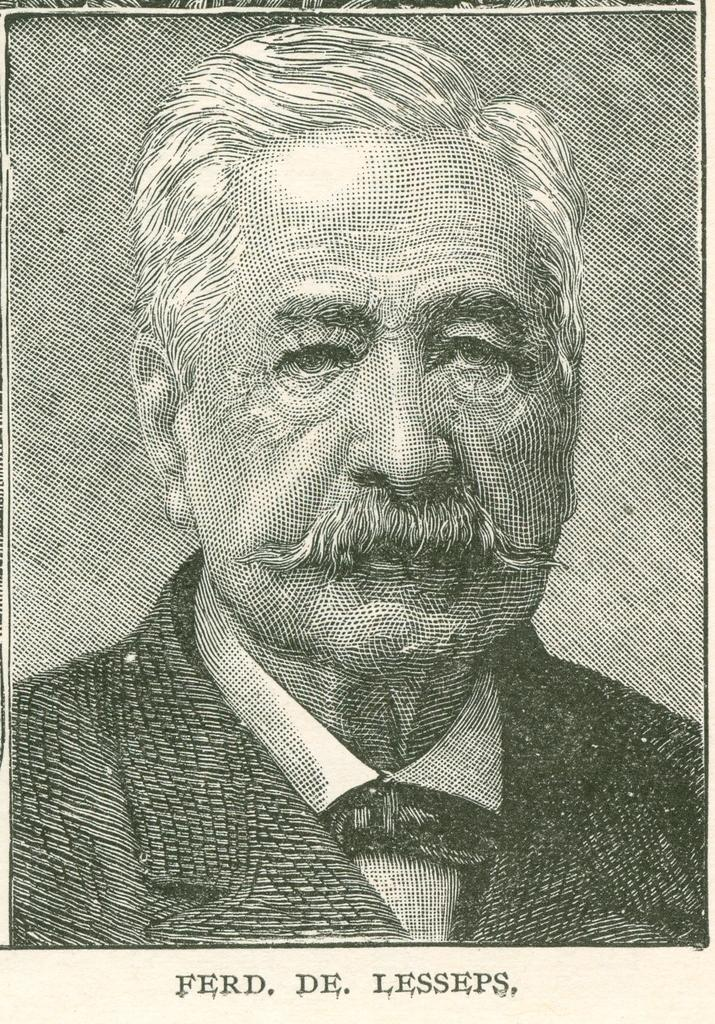What is present in the image that features an image? There is a poster in the image that contains an image. What type of image is on the poster? The image on the poster is of a man. What else can be found on the poster besides the image? There is text on the poster. How does the heat affect the poster in the image? There is no mention of heat in the image, so it cannot be determined how it might affect the poster. 